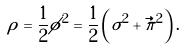Convert formula to latex. <formula><loc_0><loc_0><loc_500><loc_500>\rho = \frac { 1 } { 2 } \phi ^ { 2 } = \frac { 1 } { 2 } \left ( \sigma ^ { 2 } + \vec { \pi } ^ { 2 } \right ) .</formula> 